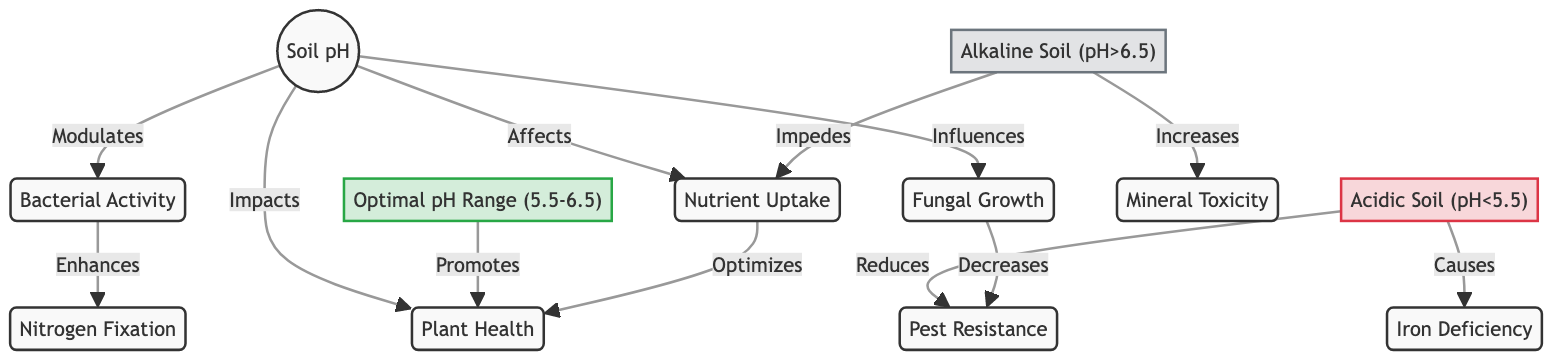What is the optimal pH range for plant health? The diagram specifically states the optimal pH range is between 5.5 and 6.5 for promoting plant health.
Answer: Optimal pH Range (5.5-6.5) Which soil condition leads to iron deficiency? The diagram indicates that acidic soil, which is defined as having a pH less than 5.5, causes iron deficiency.
Answer: Acidic Soil (pH<5.5) How does alkaline soil affect nutrient uptake? According to the diagram, alkaline soil, which has a pH greater than 6.5, impedes nutrient uptake, negatively affecting the plants' ability to absorb essential nutrients.
Answer: Impedes What is the relationship between soil pH and bacterial activity? The diagram shows that soil pH modulates bacterial activity, indicating that changes in pH directly influence how effective bacterial activity can be within the soil.
Answer: Modulates What happens to pest resistance in acidic soil? The diagram shows that acidic soil reduces pest resistance, highlighting a negative impact on the plant's ability to fend off pests when the pH is below optimal levels.
Answer: Reduces Which element enhances nitrogen fixation according to the diagram? The diagram suggests that bacterial activity enhances nitrogen fixation, indicating that higher bacterial activity in the optimal soil pH range supports this biological process.
Answer: Bacterial Activity What impact does fungal growth have on pest resistance? The diagram describes that fungal growth decreases pest resistance, portraying a negative correlation between increased fungal presence and the plant's defenses against pests.
Answer: Decreases How many nodes related to plant health are in the diagram? By analyzing the diagram, we can count the nodes that directly relate to plant health, which include Plant Health, Nutrient Uptake, Pest Resistance, and others; this totals to five nodes directly affecting plant health.
Answer: Five What effect does nutrient uptake have on plant health? The diagram specifies that nutrient uptake optimizes plant health, indicating a direct positive relationship where healthy nutrient absorption leads to better overall plant condition.
Answer: Optimizes 